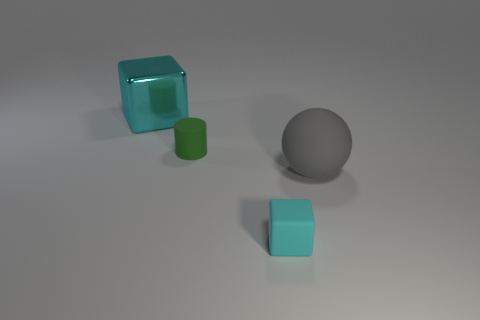Add 1 matte cylinders. How many objects exist? 5 Subtract all balls. How many objects are left? 3 Subtract 0 yellow blocks. How many objects are left? 4 Subtract all things. Subtract all blue rubber objects. How many objects are left? 0 Add 3 large rubber things. How many large rubber things are left? 4 Add 1 big shiny objects. How many big shiny objects exist? 2 